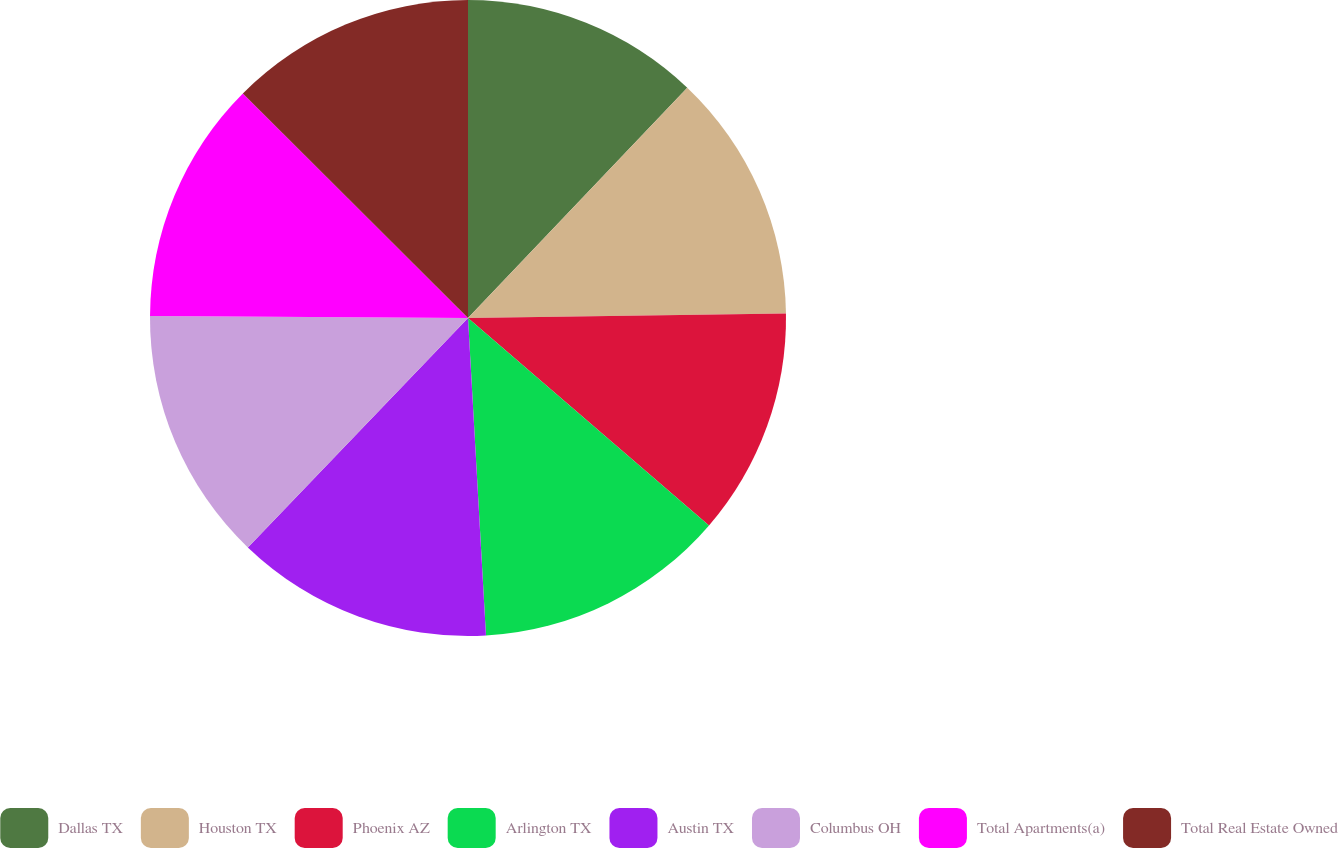Convert chart to OTSL. <chart><loc_0><loc_0><loc_500><loc_500><pie_chart><fcel>Dallas TX<fcel>Houston TX<fcel>Phoenix AZ<fcel>Arlington TX<fcel>Austin TX<fcel>Columbus OH<fcel>Total Apartments(a)<fcel>Total Real Estate Owned<nl><fcel>12.11%<fcel>12.66%<fcel>11.54%<fcel>12.79%<fcel>13.07%<fcel>12.93%<fcel>12.38%<fcel>12.52%<nl></chart> 